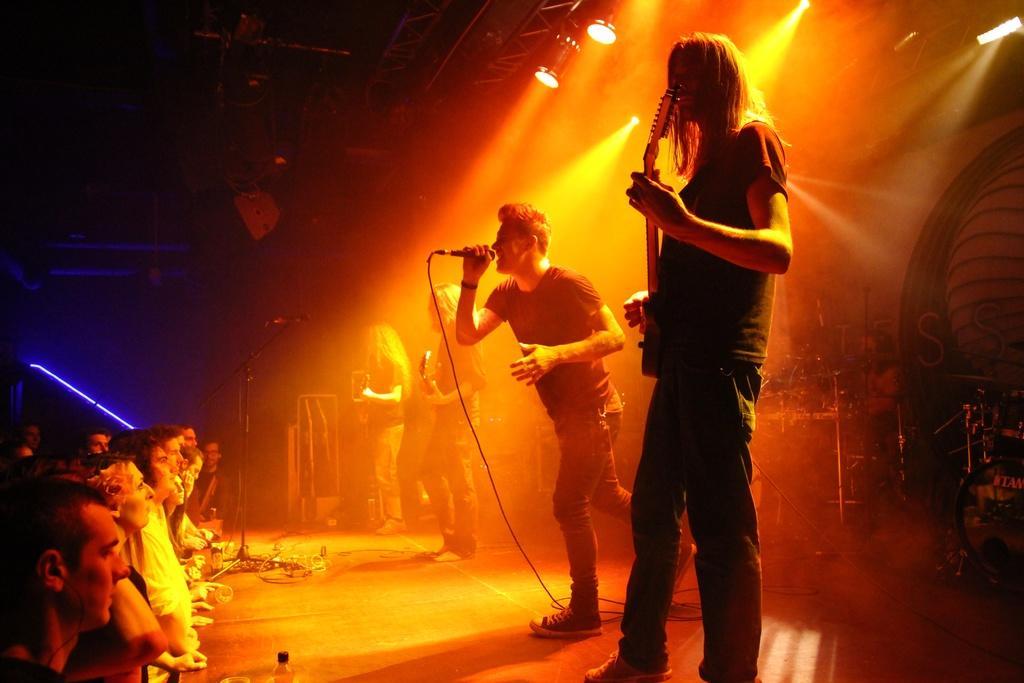In one or two sentences, can you explain what this image depicts? A rock band is performing on a stage. In the band there are three guitarists. Two men are playing drums in the background. A man is singing in center. People are watching in the front. 